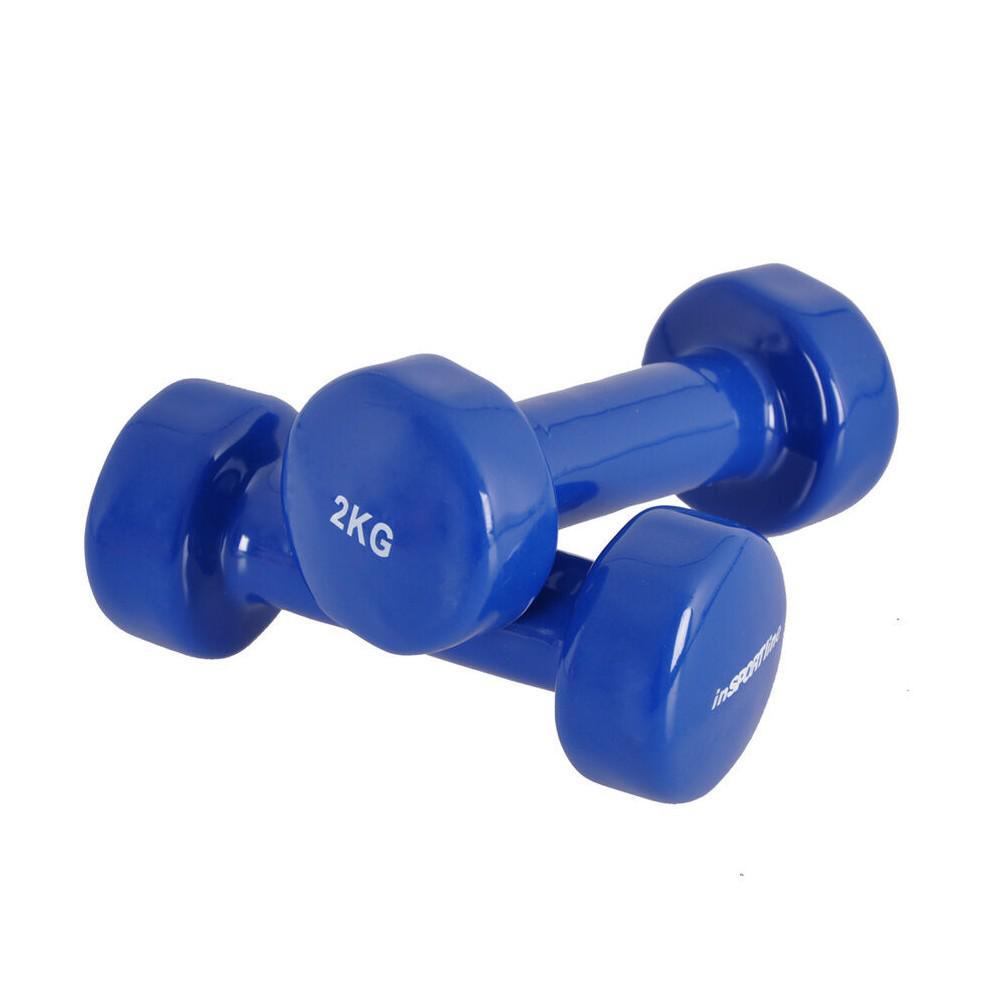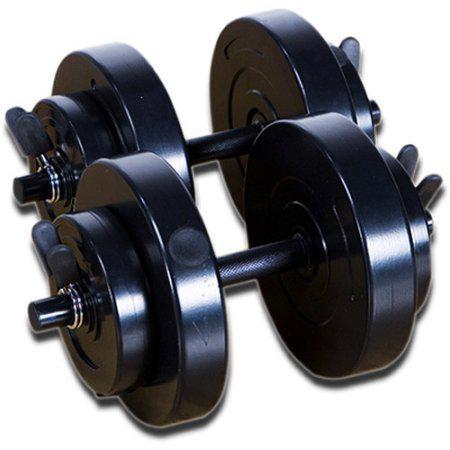The first image is the image on the left, the second image is the image on the right. Examine the images to the left and right. Is the description "In at least one image there is a total of 12 weights." accurate? Answer yes or no. No. The first image is the image on the left, the second image is the image on the right. Considering the images on both sides, is "One image features at least 10 different colors of dumbbells." valid? Answer yes or no. No. 